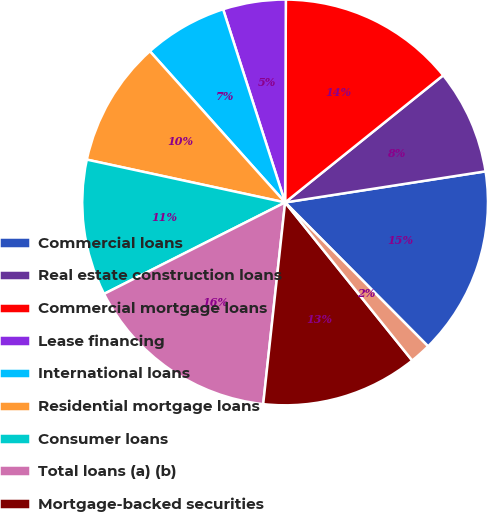<chart> <loc_0><loc_0><loc_500><loc_500><pie_chart><fcel>Commercial loans<fcel>Real estate construction loans<fcel>Commercial mortgage loans<fcel>Lease financing<fcel>International loans<fcel>Residential mortgage loans<fcel>Consumer loans<fcel>Total loans (a) (b)<fcel>Mortgage-backed securities<fcel>Other investment securities<nl><fcel>15.0%<fcel>8.33%<fcel>14.16%<fcel>5.0%<fcel>6.67%<fcel>10.0%<fcel>10.83%<fcel>15.83%<fcel>12.5%<fcel>1.67%<nl></chart> 